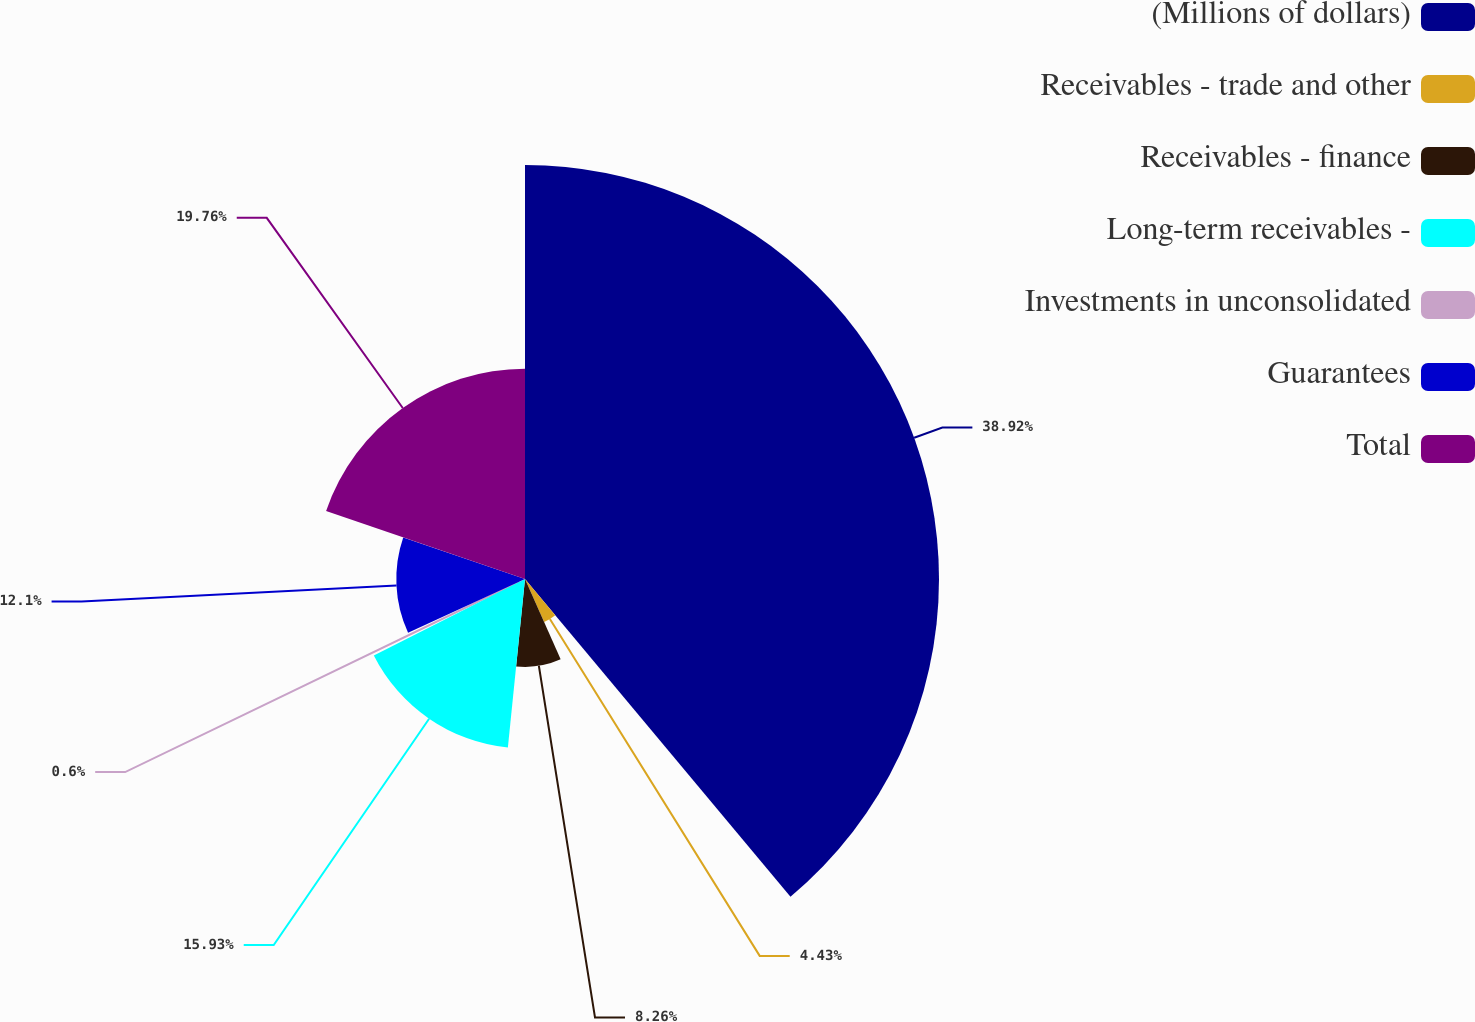Convert chart to OTSL. <chart><loc_0><loc_0><loc_500><loc_500><pie_chart><fcel>(Millions of dollars)<fcel>Receivables - trade and other<fcel>Receivables - finance<fcel>Long-term receivables -<fcel>Investments in unconsolidated<fcel>Guarantees<fcel>Total<nl><fcel>38.92%<fcel>4.43%<fcel>8.26%<fcel>15.93%<fcel>0.6%<fcel>12.1%<fcel>19.76%<nl></chart> 